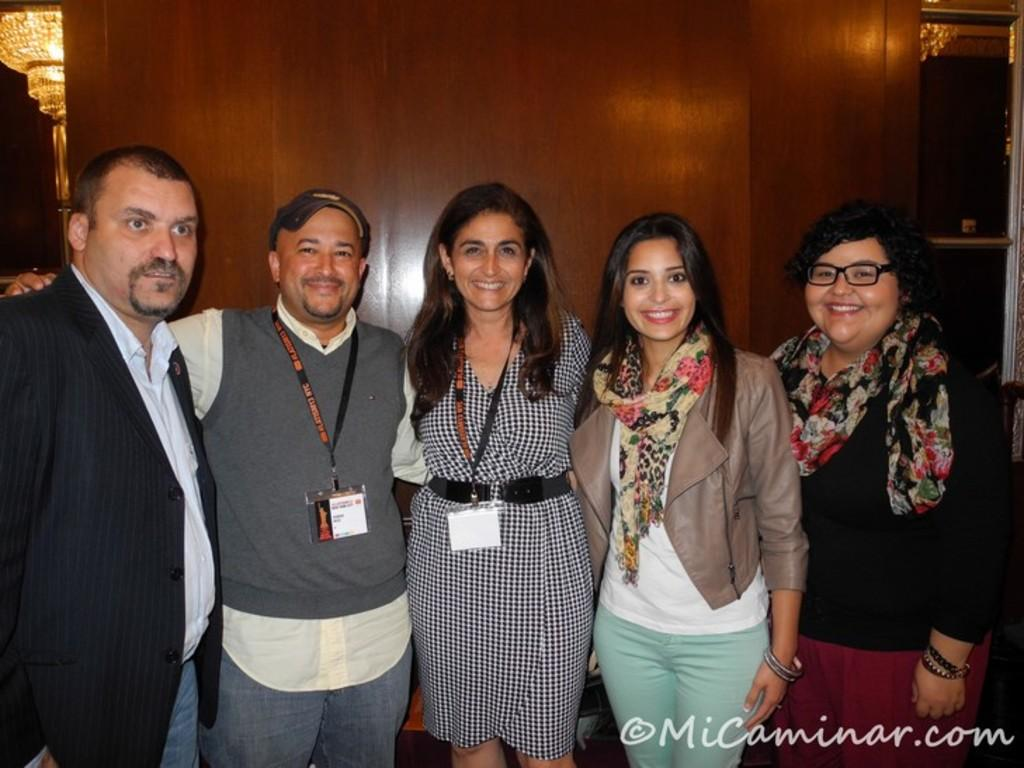How many people are in the image? There is a group of people standing in the image. Where are the people located in the image? The people are at the bottom of the image. What can be seen in the background of the image? There is a wooden wall in the background of the image. Can you describe the lighting in the image? There is a light in the top left corner of the image. What type of bloodstains can be seen on the lace in the image? There is no blood or lace present in the image. How many houses are visible in the image? There is no mention of houses in the image; it features a group of people, a wooden wall, and a light. 